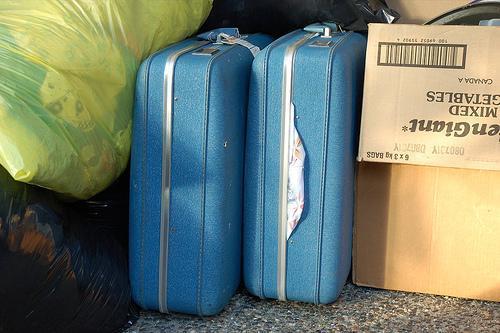How many suitcases are there?
Give a very brief answer. 2. How many containers can you see?
Give a very brief answer. 6. 